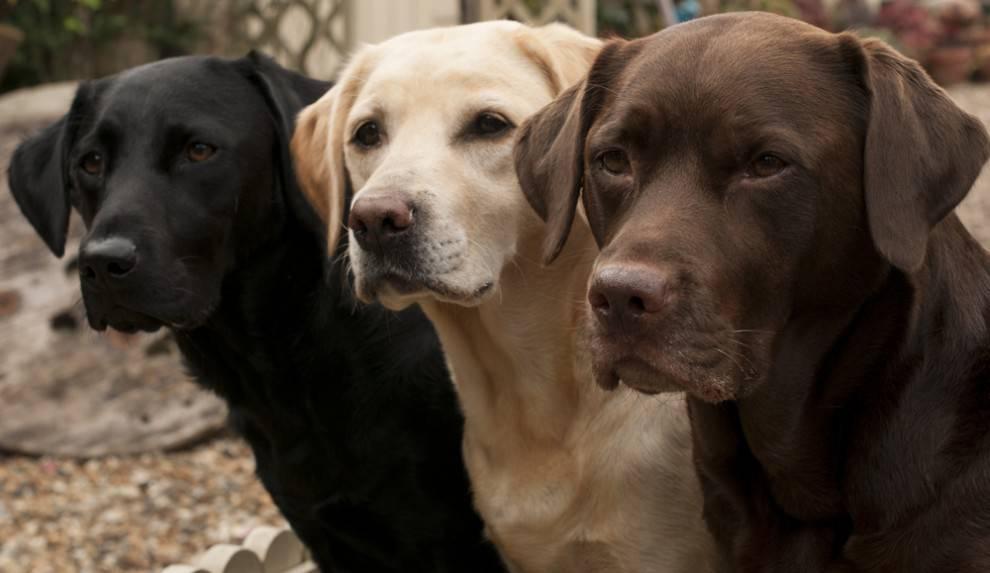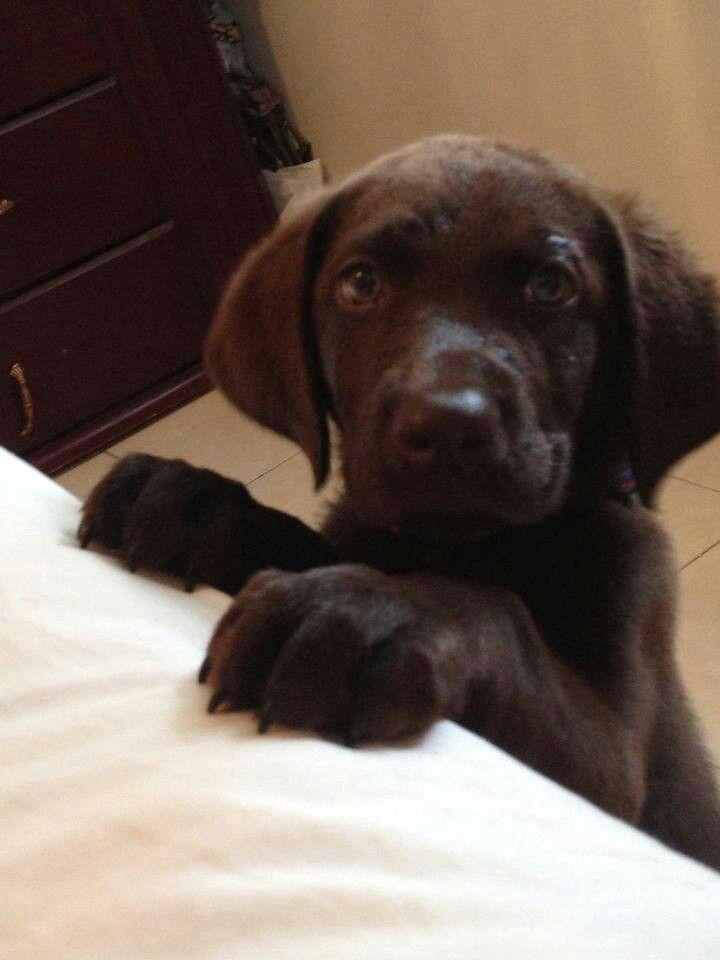The first image is the image on the left, the second image is the image on the right. Assess this claim about the two images: "One image features at least three dogs posed in a row.". Correct or not? Answer yes or no. Yes. The first image is the image on the left, the second image is the image on the right. Analyze the images presented: Is the assertion "There are no fewer than three dogs in one of the images." valid? Answer yes or no. Yes. 